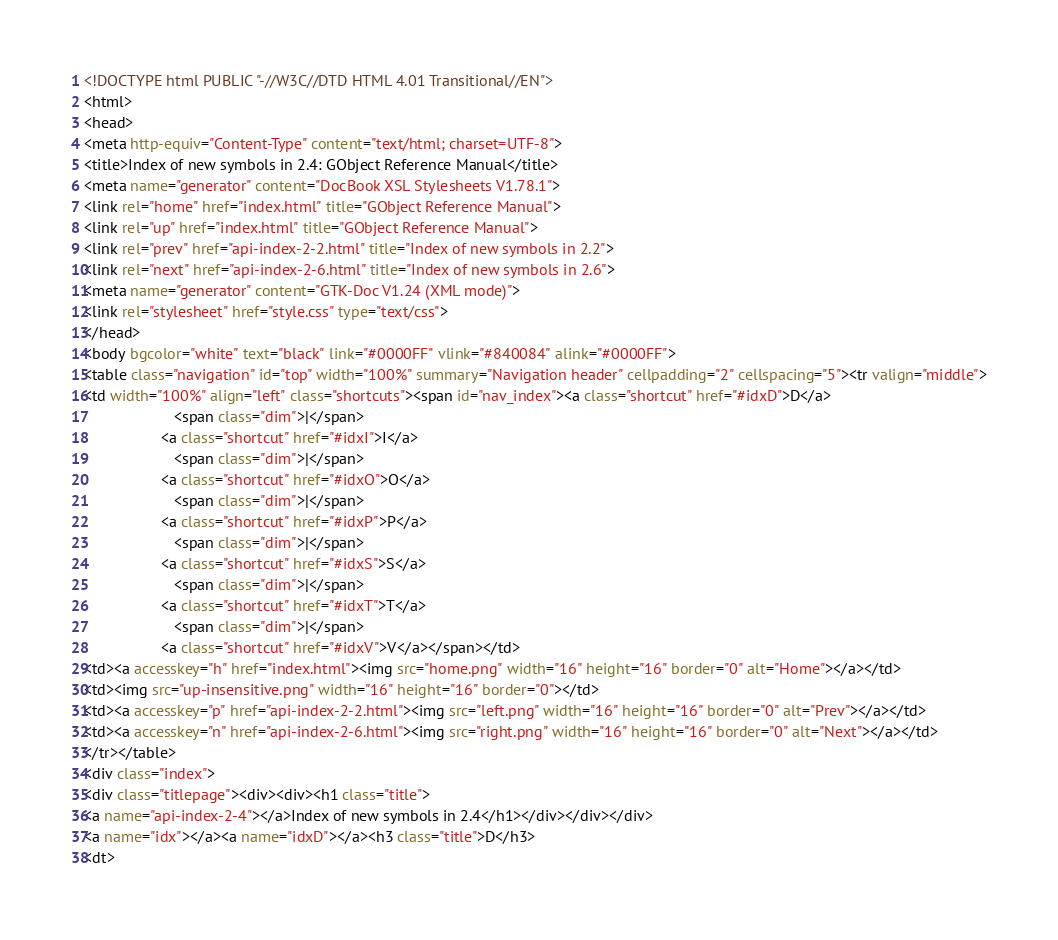Convert code to text. <code><loc_0><loc_0><loc_500><loc_500><_HTML_><!DOCTYPE html PUBLIC "-//W3C//DTD HTML 4.01 Transitional//EN">
<html>
<head>
<meta http-equiv="Content-Type" content="text/html; charset=UTF-8">
<title>Index of new symbols in 2.4: GObject Reference Manual</title>
<meta name="generator" content="DocBook XSL Stylesheets V1.78.1">
<link rel="home" href="index.html" title="GObject Reference Manual">
<link rel="up" href="index.html" title="GObject Reference Manual">
<link rel="prev" href="api-index-2-2.html" title="Index of new symbols in 2.2">
<link rel="next" href="api-index-2-6.html" title="Index of new symbols in 2.6">
<meta name="generator" content="GTK-Doc V1.24 (XML mode)">
<link rel="stylesheet" href="style.css" type="text/css">
</head>
<body bgcolor="white" text="black" link="#0000FF" vlink="#840084" alink="#0000FF">
<table class="navigation" id="top" width="100%" summary="Navigation header" cellpadding="2" cellspacing="5"><tr valign="middle">
<td width="100%" align="left" class="shortcuts"><span id="nav_index"><a class="shortcut" href="#idxD">D</a>
                     <span class="dim">|</span> 
                  <a class="shortcut" href="#idxI">I</a>
                     <span class="dim">|</span> 
                  <a class="shortcut" href="#idxO">O</a>
                     <span class="dim">|</span> 
                  <a class="shortcut" href="#idxP">P</a>
                     <span class="dim">|</span> 
                  <a class="shortcut" href="#idxS">S</a>
                     <span class="dim">|</span> 
                  <a class="shortcut" href="#idxT">T</a>
                     <span class="dim">|</span> 
                  <a class="shortcut" href="#idxV">V</a></span></td>
<td><a accesskey="h" href="index.html"><img src="home.png" width="16" height="16" border="0" alt="Home"></a></td>
<td><img src="up-insensitive.png" width="16" height="16" border="0"></td>
<td><a accesskey="p" href="api-index-2-2.html"><img src="left.png" width="16" height="16" border="0" alt="Prev"></a></td>
<td><a accesskey="n" href="api-index-2-6.html"><img src="right.png" width="16" height="16" border="0" alt="Next"></a></td>
</tr></table>
<div class="index">
<div class="titlepage"><div><div><h1 class="title">
<a name="api-index-2-4"></a>Index of new symbols in 2.4</h1></div></div></div>
<a name="idx"></a><a name="idxD"></a><h3 class="title">D</h3>
<dt></code> 